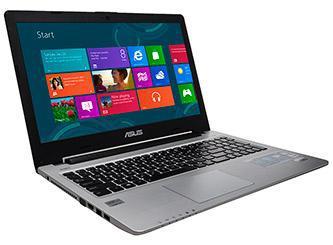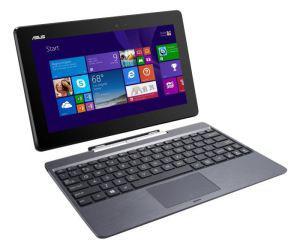The first image is the image on the left, the second image is the image on the right. Analyze the images presented: Is the assertion "The laptops face the same direction." valid? Answer yes or no. Yes. 